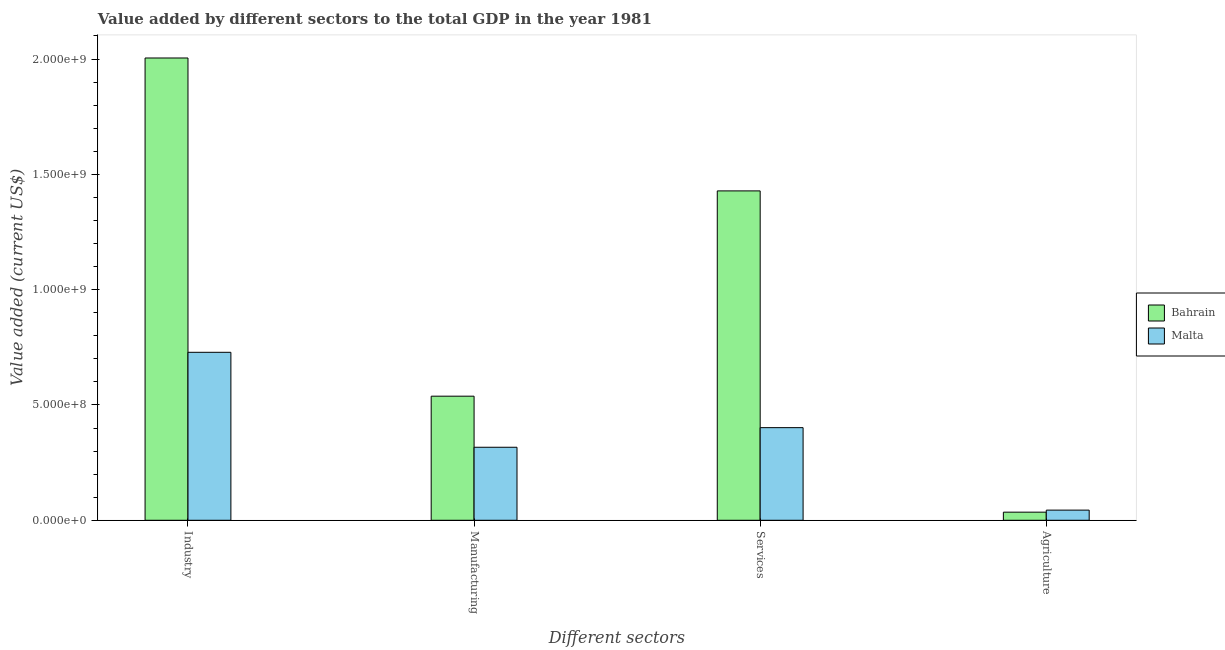How many different coloured bars are there?
Ensure brevity in your answer.  2. How many groups of bars are there?
Provide a succinct answer. 4. How many bars are there on the 2nd tick from the right?
Keep it short and to the point. 2. What is the label of the 1st group of bars from the left?
Give a very brief answer. Industry. What is the value added by manufacturing sector in Bahrain?
Your answer should be compact. 5.38e+08. Across all countries, what is the maximum value added by agricultural sector?
Provide a succinct answer. 4.40e+07. Across all countries, what is the minimum value added by agricultural sector?
Your answer should be compact. 3.51e+07. In which country was the value added by agricultural sector maximum?
Ensure brevity in your answer.  Malta. In which country was the value added by services sector minimum?
Offer a very short reply. Malta. What is the total value added by industrial sector in the graph?
Offer a very short reply. 2.73e+09. What is the difference between the value added by manufacturing sector in Bahrain and that in Malta?
Make the answer very short. 2.21e+08. What is the difference between the value added by manufacturing sector in Bahrain and the value added by services sector in Malta?
Ensure brevity in your answer.  1.36e+08. What is the average value added by manufacturing sector per country?
Your response must be concise. 4.27e+08. What is the difference between the value added by services sector and value added by agricultural sector in Bahrain?
Your answer should be compact. 1.39e+09. What is the ratio of the value added by services sector in Malta to that in Bahrain?
Provide a short and direct response. 0.28. Is the value added by manufacturing sector in Malta less than that in Bahrain?
Provide a succinct answer. Yes. Is the difference between the value added by industrial sector in Malta and Bahrain greater than the difference between the value added by services sector in Malta and Bahrain?
Offer a very short reply. No. What is the difference between the highest and the second highest value added by manufacturing sector?
Your answer should be compact. 2.21e+08. What is the difference between the highest and the lowest value added by agricultural sector?
Offer a very short reply. 8.92e+06. In how many countries, is the value added by services sector greater than the average value added by services sector taken over all countries?
Your response must be concise. 1. Is it the case that in every country, the sum of the value added by services sector and value added by industrial sector is greater than the sum of value added by agricultural sector and value added by manufacturing sector?
Give a very brief answer. No. What does the 1st bar from the left in Manufacturing represents?
Ensure brevity in your answer.  Bahrain. What does the 1st bar from the right in Agriculture represents?
Keep it short and to the point. Malta. Are all the bars in the graph horizontal?
Ensure brevity in your answer.  No. Are the values on the major ticks of Y-axis written in scientific E-notation?
Your response must be concise. Yes. How many legend labels are there?
Your response must be concise. 2. What is the title of the graph?
Your response must be concise. Value added by different sectors to the total GDP in the year 1981. What is the label or title of the X-axis?
Keep it short and to the point. Different sectors. What is the label or title of the Y-axis?
Ensure brevity in your answer.  Value added (current US$). What is the Value added (current US$) of Bahrain in Industry?
Your answer should be very brief. 2.00e+09. What is the Value added (current US$) in Malta in Industry?
Provide a succinct answer. 7.28e+08. What is the Value added (current US$) in Bahrain in Manufacturing?
Ensure brevity in your answer.  5.38e+08. What is the Value added (current US$) in Malta in Manufacturing?
Your response must be concise. 3.17e+08. What is the Value added (current US$) in Bahrain in Services?
Keep it short and to the point. 1.43e+09. What is the Value added (current US$) in Malta in Services?
Provide a succinct answer. 4.02e+08. What is the Value added (current US$) of Bahrain in Agriculture?
Keep it short and to the point. 3.51e+07. What is the Value added (current US$) in Malta in Agriculture?
Keep it short and to the point. 4.40e+07. Across all Different sectors, what is the maximum Value added (current US$) of Bahrain?
Your answer should be very brief. 2.00e+09. Across all Different sectors, what is the maximum Value added (current US$) of Malta?
Offer a terse response. 7.28e+08. Across all Different sectors, what is the minimum Value added (current US$) in Bahrain?
Your answer should be very brief. 3.51e+07. Across all Different sectors, what is the minimum Value added (current US$) in Malta?
Your response must be concise. 4.40e+07. What is the total Value added (current US$) in Bahrain in the graph?
Provide a short and direct response. 4.01e+09. What is the total Value added (current US$) of Malta in the graph?
Your answer should be compact. 1.49e+09. What is the difference between the Value added (current US$) of Bahrain in Industry and that in Manufacturing?
Your response must be concise. 1.47e+09. What is the difference between the Value added (current US$) in Malta in Industry and that in Manufacturing?
Keep it short and to the point. 4.12e+08. What is the difference between the Value added (current US$) of Bahrain in Industry and that in Services?
Your answer should be very brief. 5.76e+08. What is the difference between the Value added (current US$) of Malta in Industry and that in Services?
Your answer should be very brief. 3.27e+08. What is the difference between the Value added (current US$) of Bahrain in Industry and that in Agriculture?
Offer a very short reply. 1.97e+09. What is the difference between the Value added (current US$) in Malta in Industry and that in Agriculture?
Keep it short and to the point. 6.84e+08. What is the difference between the Value added (current US$) in Bahrain in Manufacturing and that in Services?
Offer a very short reply. -8.90e+08. What is the difference between the Value added (current US$) of Malta in Manufacturing and that in Services?
Keep it short and to the point. -8.50e+07. What is the difference between the Value added (current US$) of Bahrain in Manufacturing and that in Agriculture?
Provide a succinct answer. 5.03e+08. What is the difference between the Value added (current US$) in Malta in Manufacturing and that in Agriculture?
Make the answer very short. 2.73e+08. What is the difference between the Value added (current US$) of Bahrain in Services and that in Agriculture?
Your answer should be very brief. 1.39e+09. What is the difference between the Value added (current US$) of Malta in Services and that in Agriculture?
Your answer should be very brief. 3.58e+08. What is the difference between the Value added (current US$) of Bahrain in Industry and the Value added (current US$) of Malta in Manufacturing?
Ensure brevity in your answer.  1.69e+09. What is the difference between the Value added (current US$) of Bahrain in Industry and the Value added (current US$) of Malta in Services?
Your response must be concise. 1.60e+09. What is the difference between the Value added (current US$) of Bahrain in Industry and the Value added (current US$) of Malta in Agriculture?
Your answer should be very brief. 1.96e+09. What is the difference between the Value added (current US$) of Bahrain in Manufacturing and the Value added (current US$) of Malta in Services?
Offer a terse response. 1.36e+08. What is the difference between the Value added (current US$) in Bahrain in Manufacturing and the Value added (current US$) in Malta in Agriculture?
Offer a very short reply. 4.94e+08. What is the difference between the Value added (current US$) of Bahrain in Services and the Value added (current US$) of Malta in Agriculture?
Offer a terse response. 1.38e+09. What is the average Value added (current US$) in Bahrain per Different sectors?
Keep it short and to the point. 1.00e+09. What is the average Value added (current US$) in Malta per Different sectors?
Your answer should be very brief. 3.73e+08. What is the difference between the Value added (current US$) in Bahrain and Value added (current US$) in Malta in Industry?
Offer a terse response. 1.28e+09. What is the difference between the Value added (current US$) in Bahrain and Value added (current US$) in Malta in Manufacturing?
Your answer should be compact. 2.21e+08. What is the difference between the Value added (current US$) of Bahrain and Value added (current US$) of Malta in Services?
Offer a terse response. 1.03e+09. What is the difference between the Value added (current US$) in Bahrain and Value added (current US$) in Malta in Agriculture?
Your answer should be very brief. -8.92e+06. What is the ratio of the Value added (current US$) in Bahrain in Industry to that in Manufacturing?
Make the answer very short. 3.73. What is the ratio of the Value added (current US$) in Malta in Industry to that in Manufacturing?
Offer a terse response. 2.3. What is the ratio of the Value added (current US$) of Bahrain in Industry to that in Services?
Your answer should be compact. 1.4. What is the ratio of the Value added (current US$) of Malta in Industry to that in Services?
Your answer should be very brief. 1.81. What is the ratio of the Value added (current US$) in Bahrain in Industry to that in Agriculture?
Provide a succinct answer. 57.1. What is the ratio of the Value added (current US$) of Malta in Industry to that in Agriculture?
Your answer should be very brief. 16.54. What is the ratio of the Value added (current US$) of Bahrain in Manufacturing to that in Services?
Make the answer very short. 0.38. What is the ratio of the Value added (current US$) in Malta in Manufacturing to that in Services?
Offer a terse response. 0.79. What is the ratio of the Value added (current US$) of Bahrain in Manufacturing to that in Agriculture?
Offer a very short reply. 15.33. What is the ratio of the Value added (current US$) of Malta in Manufacturing to that in Agriculture?
Ensure brevity in your answer.  7.19. What is the ratio of the Value added (current US$) of Bahrain in Services to that in Agriculture?
Make the answer very short. 40.68. What is the ratio of the Value added (current US$) of Malta in Services to that in Agriculture?
Ensure brevity in your answer.  9.12. What is the difference between the highest and the second highest Value added (current US$) in Bahrain?
Offer a very short reply. 5.76e+08. What is the difference between the highest and the second highest Value added (current US$) in Malta?
Offer a very short reply. 3.27e+08. What is the difference between the highest and the lowest Value added (current US$) of Bahrain?
Offer a very short reply. 1.97e+09. What is the difference between the highest and the lowest Value added (current US$) of Malta?
Your response must be concise. 6.84e+08. 